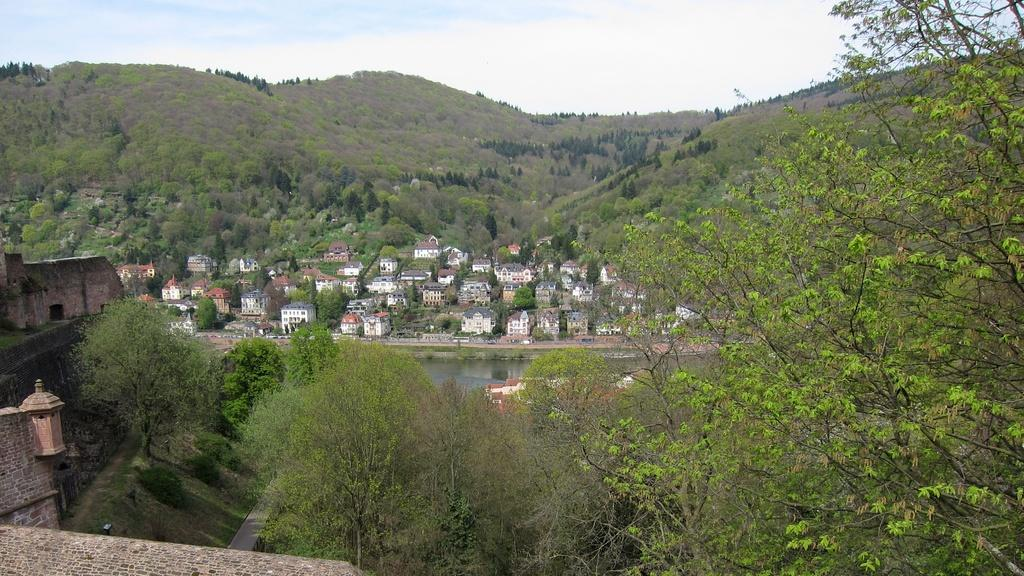What type of natural landscape is depicted in the image? The image features mountains and many trees. Are there any man-made structures visible in the image? Yes, buildings are present in the image. What type of water body can be seen in the image? There is a water body in the image. How many toothbrushes can be seen in the image? There are no toothbrushes present in the image. What type of experience can be gained from the image? The image itself does not provide an experience, but it may evoke feelings or thoughts about nature and landscapes. 